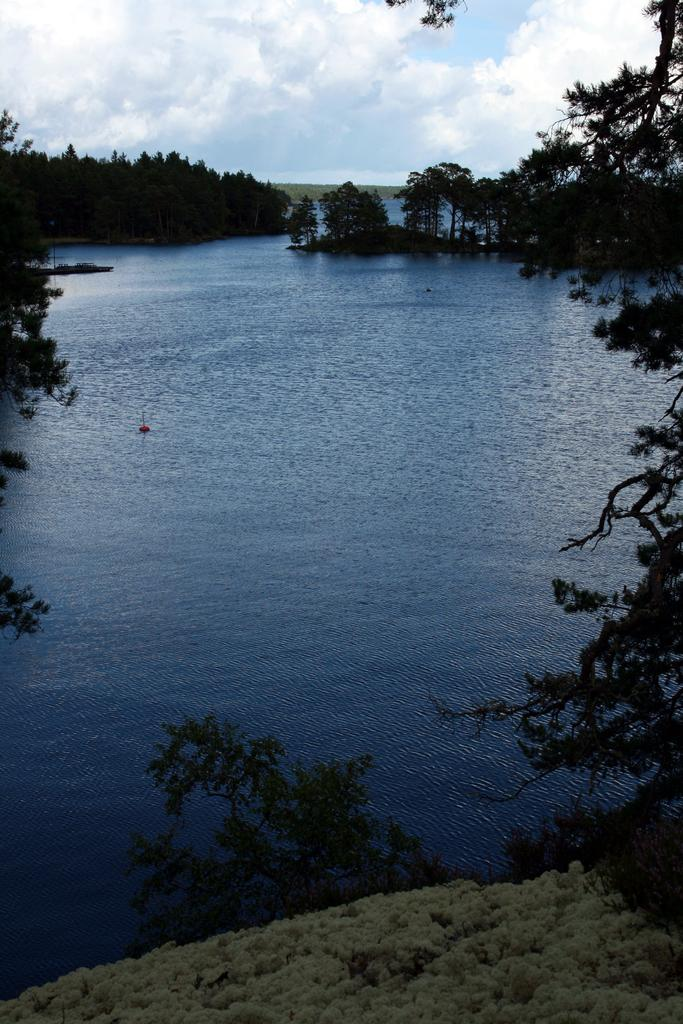What is the main element visible in the image? There is water in the image. What type of ground can be seen in the image? The ground in the image contains grass. What other types of vegetation are present in the image? Plants are present on the ground in the image, and trees are visible as well. What can be seen in the sky in the image? Clouds are present in the sky in the image. What is the income of the person who owns the land in the image? There is no information about the income of the person who owns the land in the image. How does the care of the plants in the image affect their growth? There is no information about the care of the plants in the image, so we cannot determine how it affects their growth. 